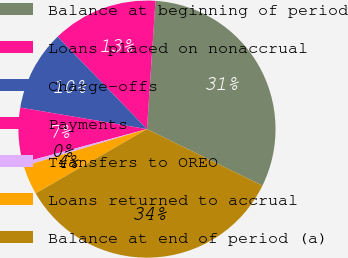<chart> <loc_0><loc_0><loc_500><loc_500><pie_chart><fcel>Balance at beginning of period<fcel>Loans placed on nonaccrual<fcel>Charge-offs<fcel>Payments<fcel>Transfers to OREO<fcel>Loans returned to accrual<fcel>Balance at end of period (a)<nl><fcel>31.2%<fcel>13.29%<fcel>10.08%<fcel>6.88%<fcel>0.47%<fcel>3.67%<fcel>34.41%<nl></chart> 